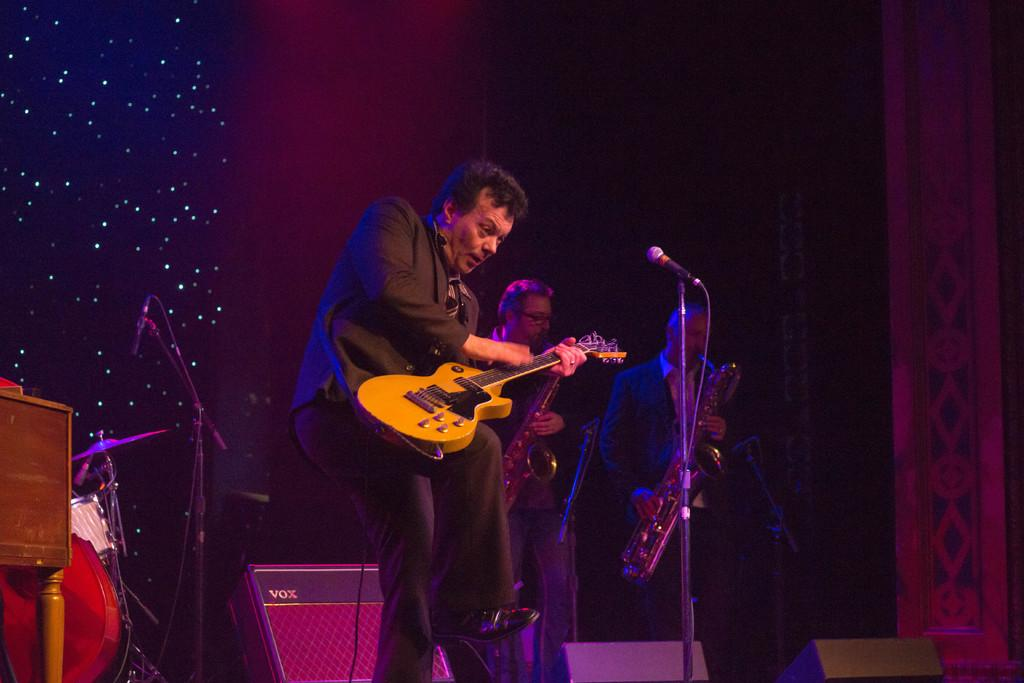What is the man in the image doing? The man is playing a guitar in the image. What object is in front of the man? There is a microphone in front of the man. Where is the scene taking place? The scene takes place on a stage. What might the man be doing on the stage? The man might be performing, given the presence of a guitar and microphone. What position does the man's grandfather hold in the image? There is no mention of a grandfather in the image, so it is not possible to determine any position he might hold. 